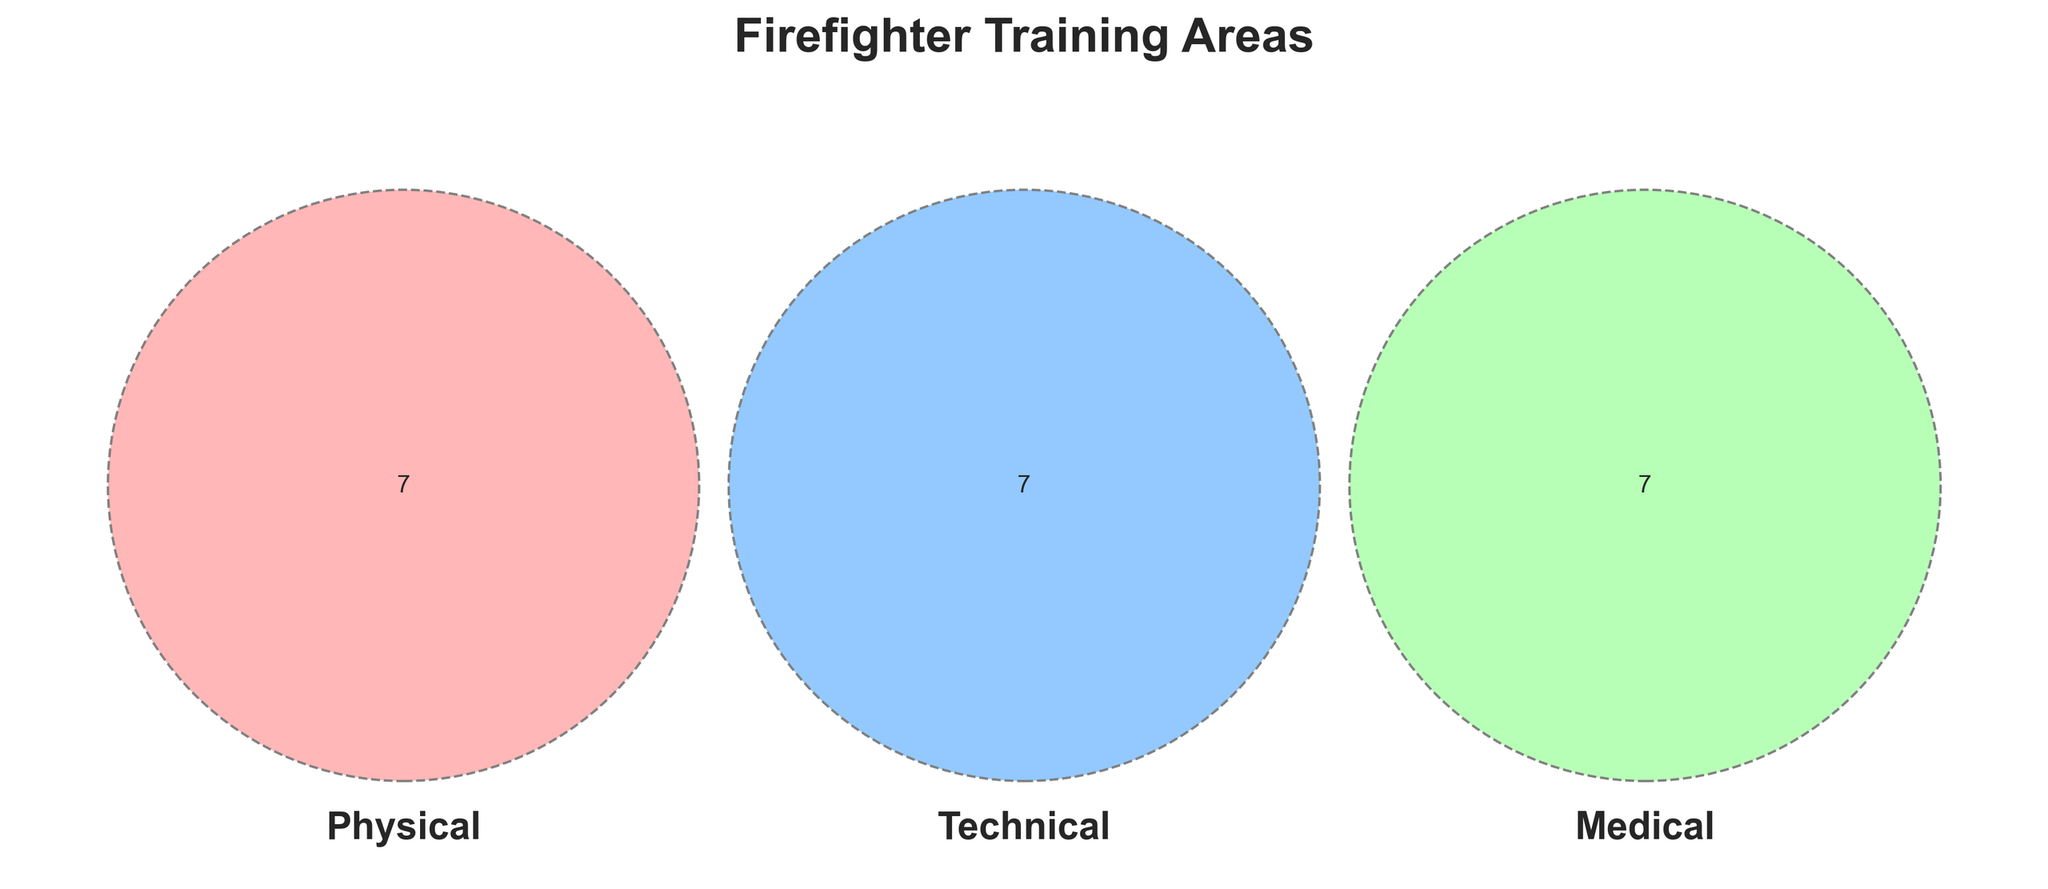What are the training areas in the Physical section? The Venn diagram visualizes different training areas in overlaps and non-overlaps for Physical, Technical, and Medical sections. The standalone Physical section includes fitness, strength training, endurance, agility, heat tolerance, confined space, and ladder climbing.
Answer: Fitness, Strength training, Endurance, Agility, Heat tolerance, Confined space, Ladder climbing How many training areas overlap between the Physical and Technical sections? To find the overlapping areas in a Venn diagram, locate the common section between Physical and Technical sets. The absence of any label in the overlapping section implies no common training areas.
Answer: 0 Which training areas fall under both Medical and Technical sections? Look at the section where the Medical and Technical circles overlap. Since no specific training areas are listed in this overlap, there are no common training areas between Medical and Technical.
Answer: None How many unique training areas are in the diagram? Each Venn diagram area representing distinct training within Physical, Technical, and Medical counts towards unique areas. Sum the total: Physical (7) + Technical (7) + Medical (7) = 21 unique areas.
Answer: 21 Do Physical and Medical sections share any common training areas? Identify the overlapping part between Physical and Medical sets in the Venn diagram. As no shared points are noted in this overlapping, there are no common training areas between them.
Answer: No What section has the most training areas exclusive to it? Compare the standalone sections. Each (Physical, Technical, Medical) has seven areas exclusively. Thus, all three have the same number of exclusive training areas.
Answer: All three Which training areas are solely listed in the Medical section? Observe the exclusively Medical segment including first aid, CPR, burn treatment, smoke inhalation, triage, defibrillator use, and vital signs assessment.
Answer: First aid, CPR, Burn treatment, Smoke inhalation, Triage, Defibrillator use, Vital signs assessment Which section includes 'Pump operations'? Locate 'Pump operations' in the Venn diagram. It is listed under the Technical segment.
Answer: Technical Are there any common training areas amongst all three sections (Physical, Technical, Medical)? Check for any overlap among all three circles. Since no areas intersect in their common center segment, no training areas are shared among all three.
Answer: None What types of training are covered under the Technical section? The Technical section of the Venn diagram includes equipment use, fire behavior, rescue techniques, hazmat handling, hydraulics, communication systems, and pump operations training areas.
Answer: Equipment use, Fire behavior, Rescue techniques, Hazmat handling, Hydraulics, Communication systems, Pump operations 